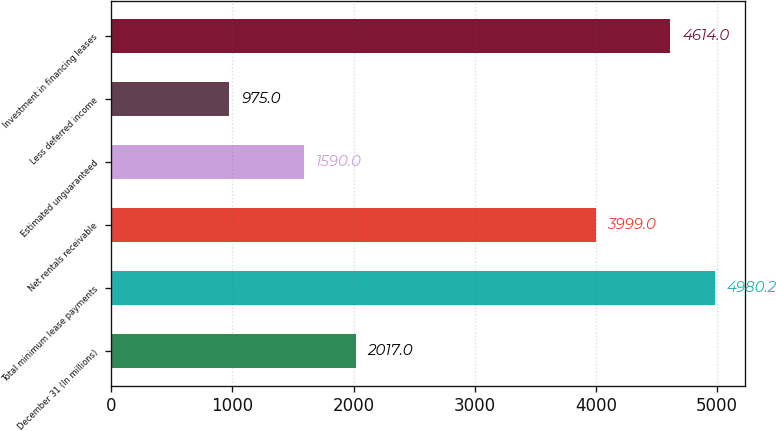Convert chart. <chart><loc_0><loc_0><loc_500><loc_500><bar_chart><fcel>December 31 (In millions)<fcel>Total minimum lease payments<fcel>Net rentals receivable<fcel>Estimated unguaranteed<fcel>Less deferred income<fcel>Investment in financing leases<nl><fcel>2017<fcel>4980.2<fcel>3999<fcel>1590<fcel>975<fcel>4614<nl></chart> 